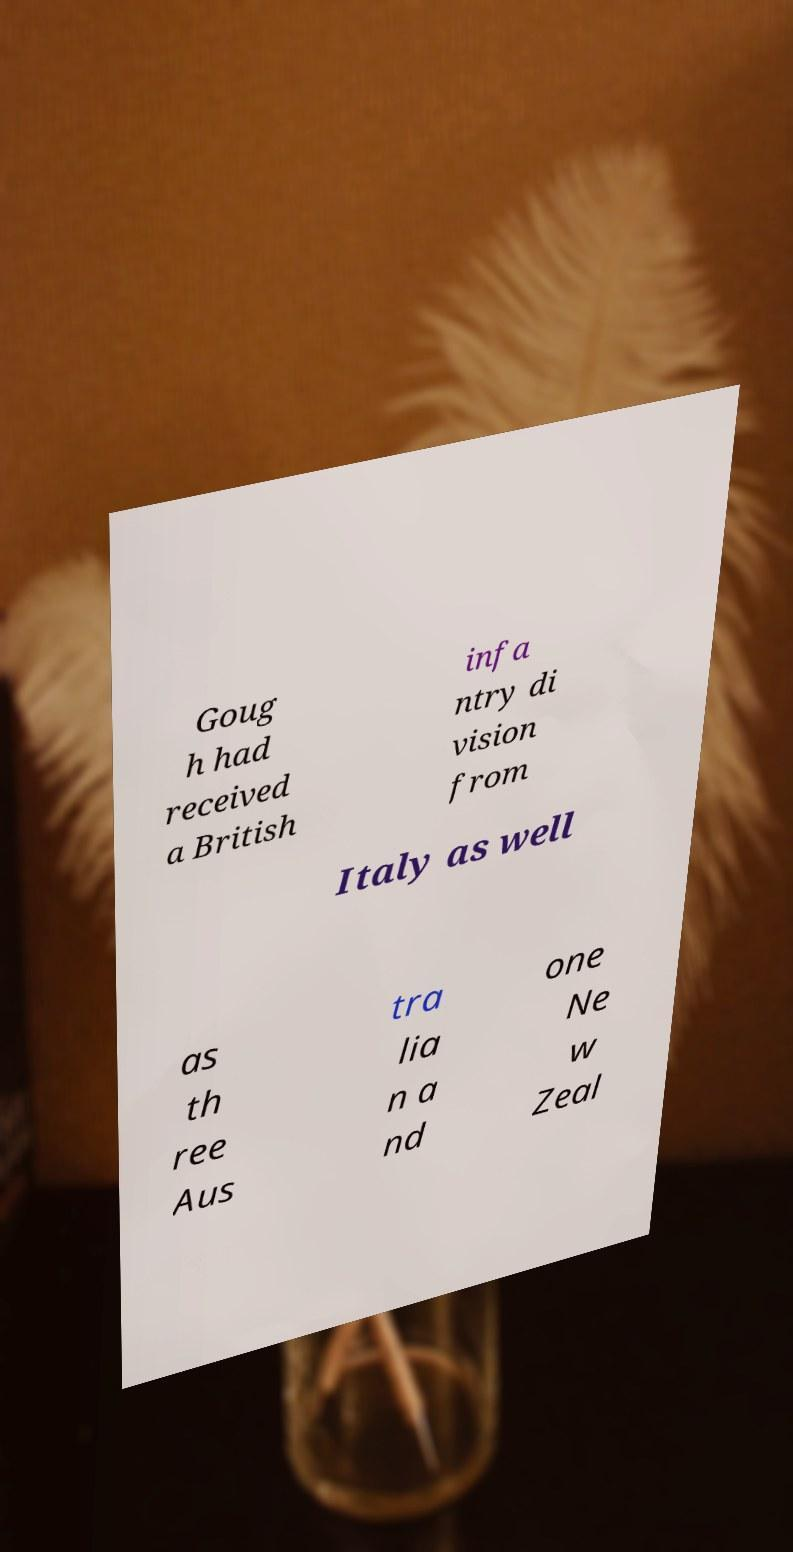Could you assist in decoding the text presented in this image and type it out clearly? Goug h had received a British infa ntry di vision from Italy as well as th ree Aus tra lia n a nd one Ne w Zeal 